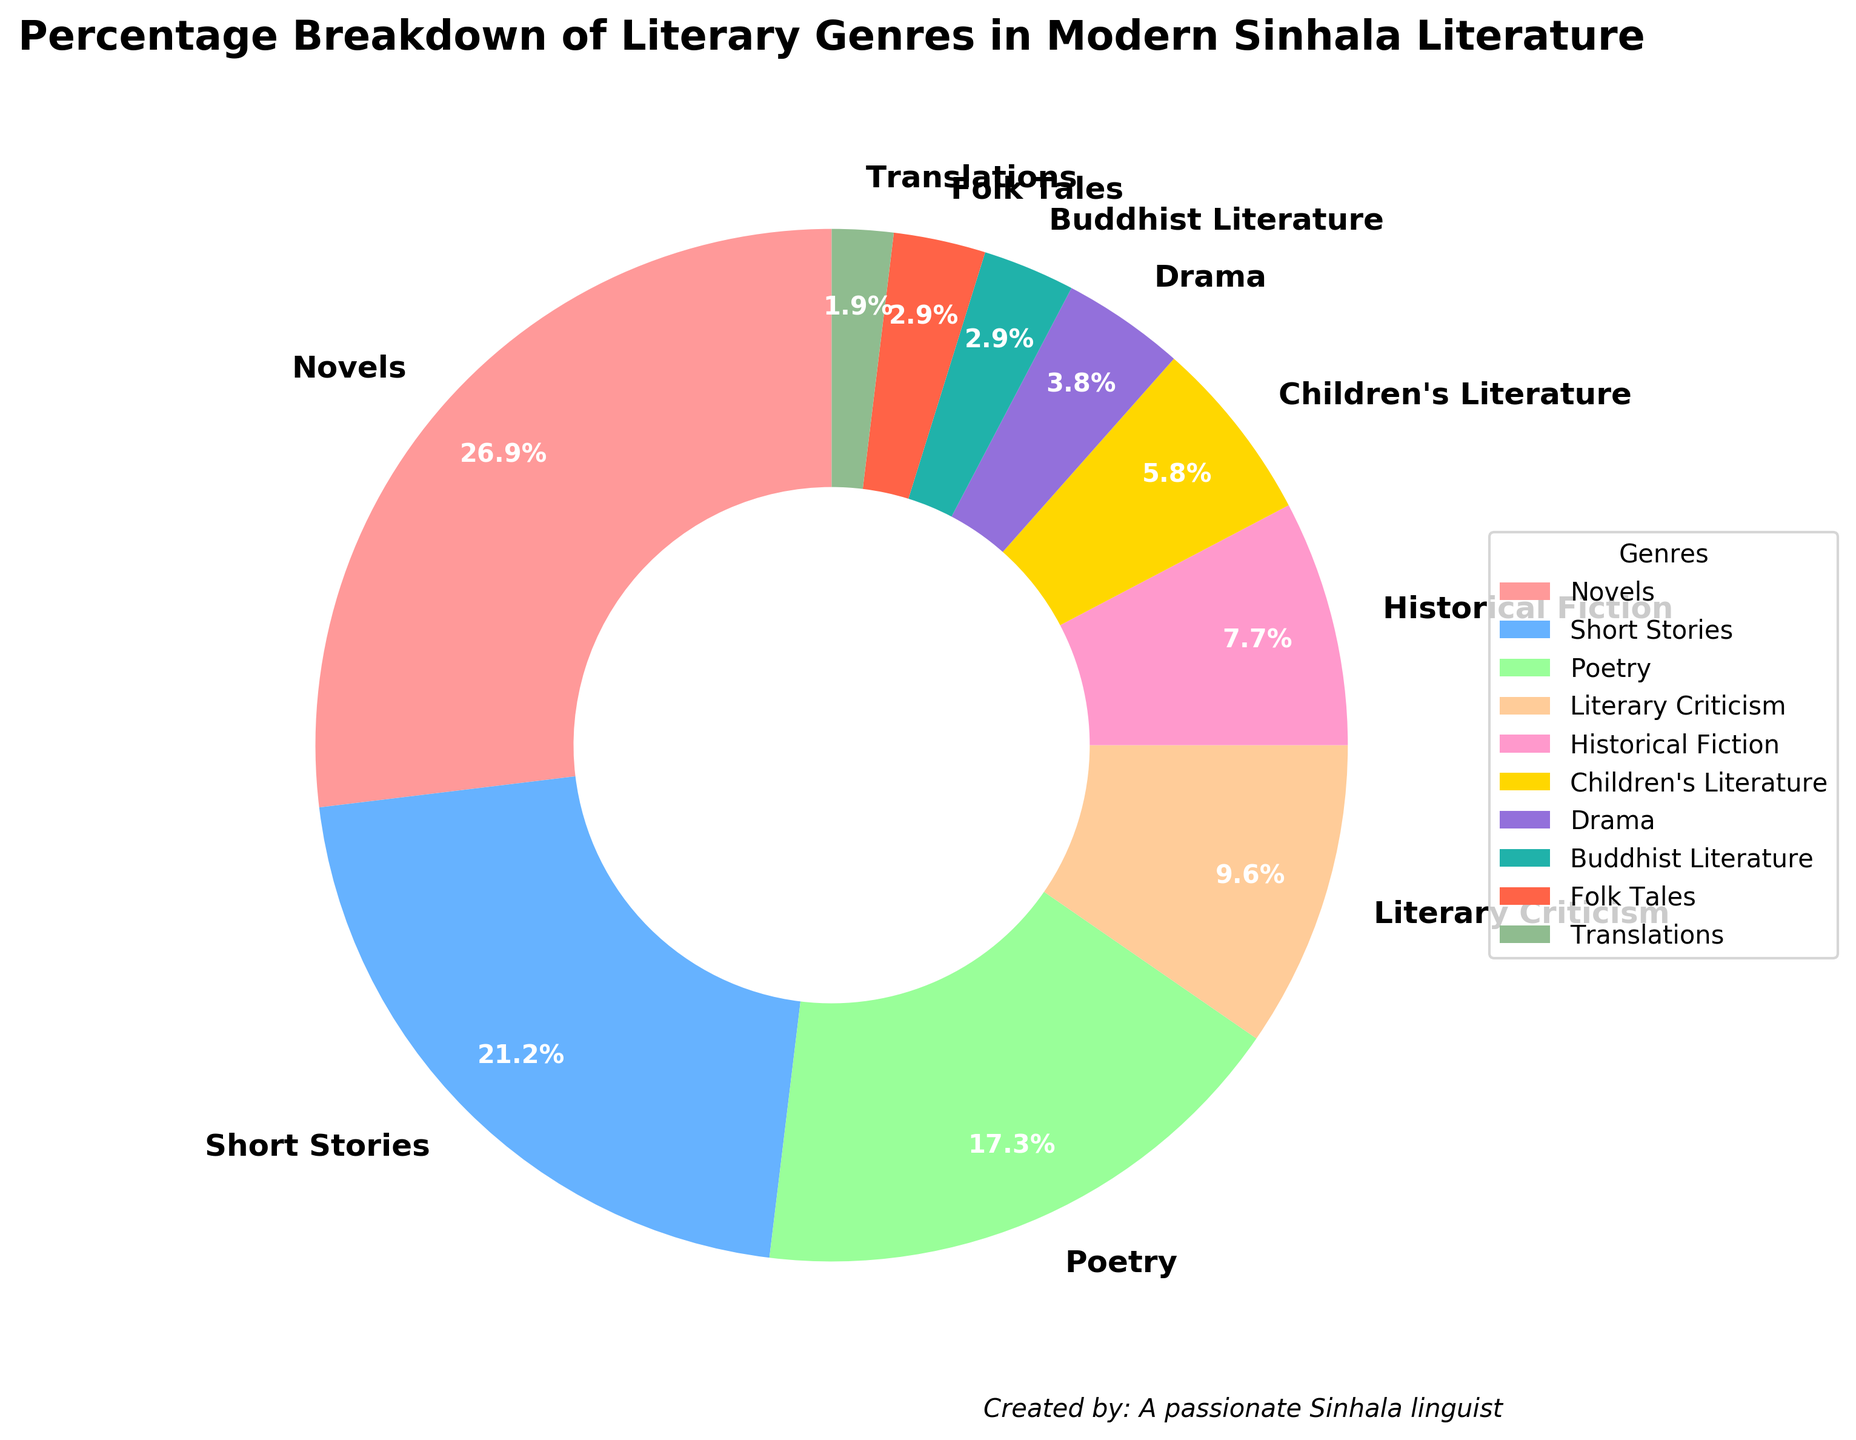What is the genre with the highest percentage in modern Sinhala literature? The genre with the highest percentage can be identified by looking for the largest segment in the pie chart. In this case, the "Novels" segment is the largest.
Answer: Novels Which two genres together make up exactly 6% of modern Sinhala literature? To find two genres that together make up 6%, we look for segments that sum to 6%. The "Children's Literature" segment is 6%, but specifically asking for two genres, we find "Buddhist Literature" (3%) combined with "Folk Tales" (3%) also makes up 6%.
Answer: Buddhist Literature and Folk Tales How many genres have a percentage higher than 10%? To determine how many genres are higher than 10%, count the segments that have labels indicating percentages over 10%. The segments for "Novels" (28%), "Short Stories" (22%), and "Poetry" (18%) fit this criterion.
Answer: 3 Which genre has the smallest percentage in modern Sinhala literature? The smallest segment in the pie chart represents the genre with the smallest percentage. In this case, the "Translations" segment is the smallest.
Answer: Translations What percentage of modern Sinhala literature is made up of Drama and Historical Fiction combined? To find the combined percentage of Drama and Historical Fiction, add their percentages: 4% (Drama) + 8% (Historical Fiction) = 12%.
Answer: 12% Which genre is represented by the yellow segment in the pie chart? Identify the yellow segment in the chart and read its corresponding label. The yellow segment represents "Children's Literature".
Answer: Children's Literature Compare the percentages of Folk Tales and Literary Criticism. Which genre is more prominent, and by how much? Look at the segments for Folk Tales (3%) and Literary Criticism (10%) and compute the difference. Literary Criticism is more prominent by 10% - 3% = 7%.
Answer: Literary Criticism by 7% What is the total combined percentage of the three least represented genres in modern Sinhala literature? Identify the three smallest segments in the pie chart: Translations (2%), Buddhist Literature (3%), and Folk Tales (3%). Their combined percentage is 2% + 3% + 3% = 8%.
Answer: 8% If you combine the genres of literary works related to children, both directly and indirectly, what percentage does it represent? Combine the percentages of Children's Literature (6%) and Folk Tales (3%), as these genres often relate to children. The total is 6% + 3% = 9%.
Answer: 9% What percentage does poetry contribute to modern Sinhala literature compared to novels? Look at the percentages for Poetry (18%) and Novels (28%) and compute the ratio (Poetry / Novels * 100) = (18% / 28%) * 100 ≈ 64.3%.
Answer: 64.3% 